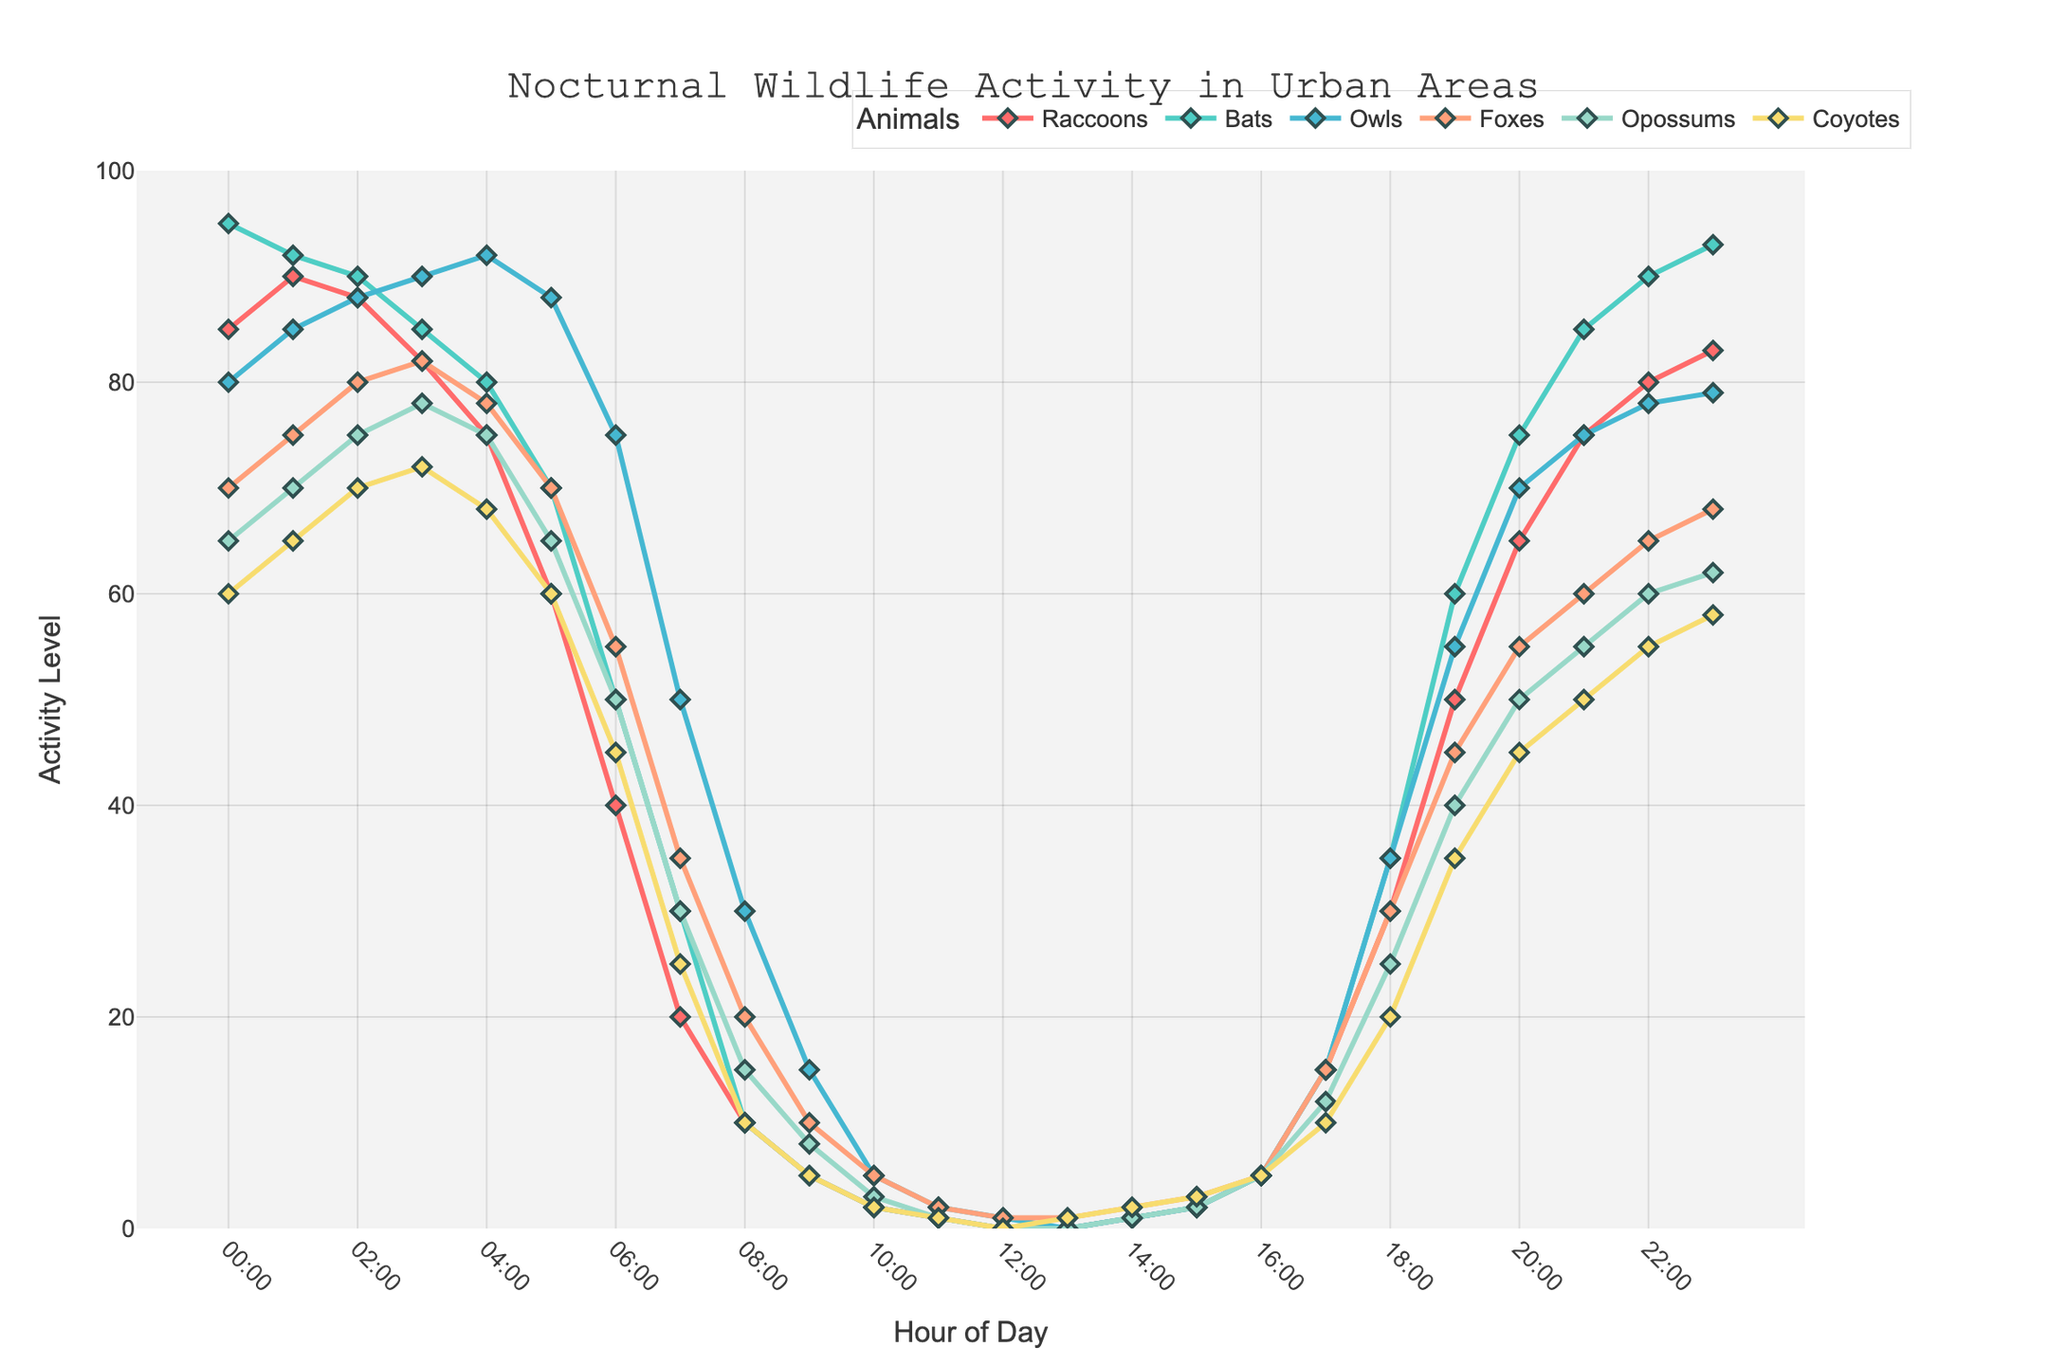Which animal shows the highest activity level at 2:00 AM? From the figure, identify the points of activity levels for all animals at 2:00 AM. Compare these values. Bats show the highest activity level of 90 at 2:00 AM.
Answer: Bats At what time does the activity level of raccoons start to increase after their lowest point? Look at the activity pattern of raccoons and identify the lowest point. Raccoons hit their lowest activity point at 12:00 PM and start to increase at 1:00 PM.
Answer: 1:00 PM Which two animals have the most similar activity patterns between 10:00 PM and 2:00 AM? Examine the activity levels of all animals between 10:00 PM and 2:00 AM and find those with the closest values at each hour. Bats and Raccoons have the most similar activity patterns in this time frame.
Answer: Bats and Raccoons At 5:00 AM, what is the difference in activity levels between coyotes and raccoons? Check the activity levels for coyotes and raccoons at 5:00 AM, then subtract the smaller value from the larger one. Coyotes' activity is 60 and raccoons' is 60 at 5:00 AM, so the difference is 60 - 60 = 0.
Answer: 0 What is the average activity level of owls between midnight (00:00) and 4:00 AM? Add the activity levels of owls at 00:00, 01:00, 02:00, 03:00, and 04:00, then divide by the number of data points (5). The values are 80, 85, 88, 90, 92, and their sum is 435. Dividing by 5 gives an average of 87.
Answer: 87 Which animal has the lowest activity level at noon (12:00 PM)? Check the activity levels recorded at 12:00 PM for all animals and find the one with the lowest value. Raccoons, Bats, Opossums, and Coyotes all have the lowest activity level of 0 at 12:00 PM.
Answer: Raccoons, Bats, Opossums, Coyotes At 10:00 PM, which animal has the second-highest activity level? First, identify the activity levels of all animals at 10:00 PM, then sort these values to find the second-highest one. Owls have the highest with 78, Bats come next with 90.
Answer: Bats 